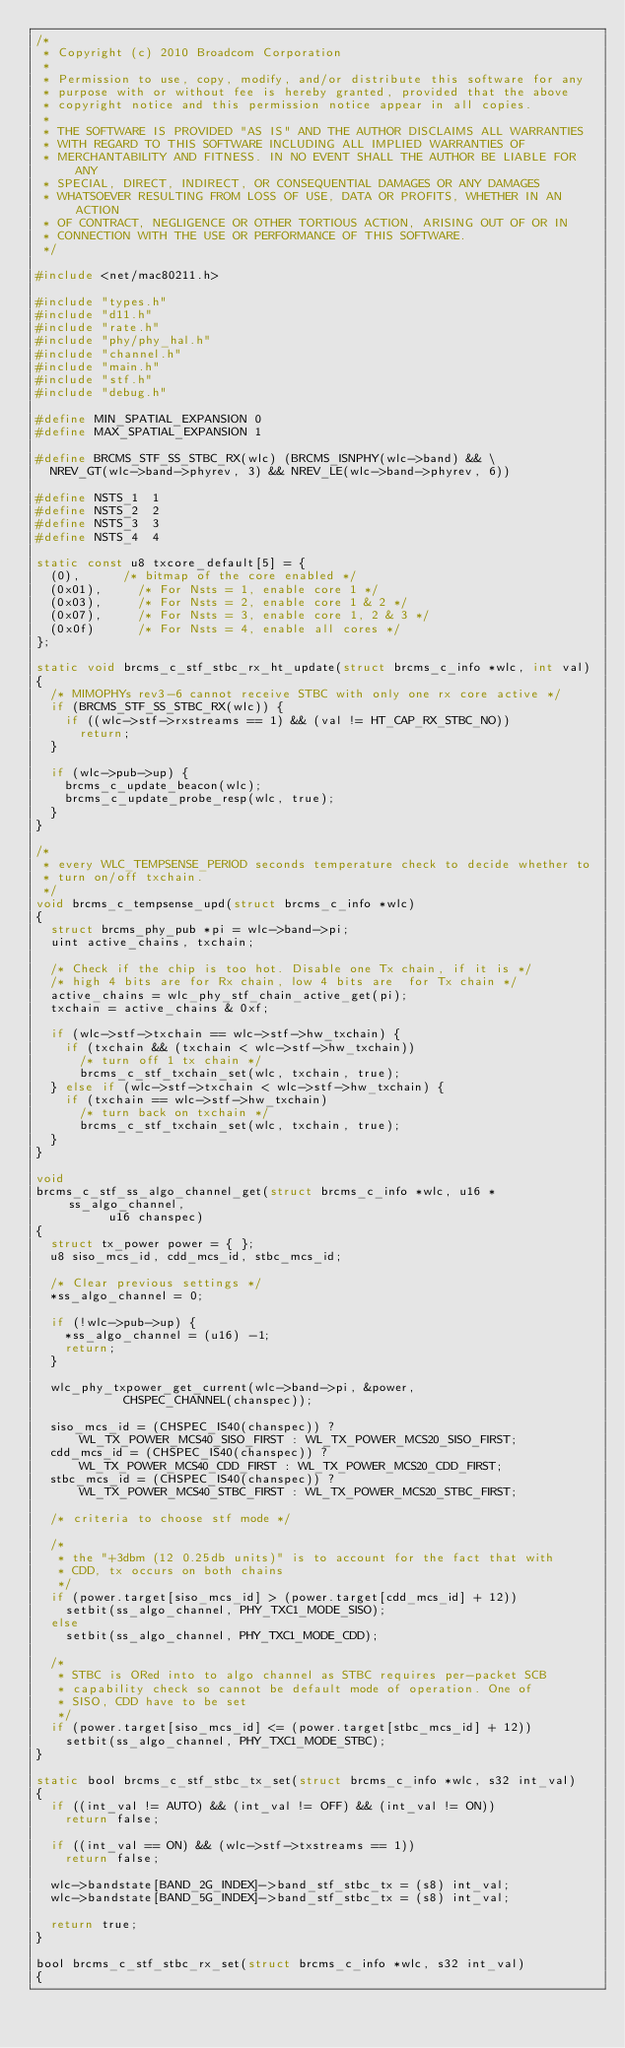Convert code to text. <code><loc_0><loc_0><loc_500><loc_500><_C_>/*
 * Copyright (c) 2010 Broadcom Corporation
 *
 * Permission to use, copy, modify, and/or distribute this software for any
 * purpose with or without fee is hereby granted, provided that the above
 * copyright notice and this permission notice appear in all copies.
 *
 * THE SOFTWARE IS PROVIDED "AS IS" AND THE AUTHOR DISCLAIMS ALL WARRANTIES
 * WITH REGARD TO THIS SOFTWARE INCLUDING ALL IMPLIED WARRANTIES OF
 * MERCHANTABILITY AND FITNESS. IN NO EVENT SHALL THE AUTHOR BE LIABLE FOR ANY
 * SPECIAL, DIRECT, INDIRECT, OR CONSEQUENTIAL DAMAGES OR ANY DAMAGES
 * WHATSOEVER RESULTING FROM LOSS OF USE, DATA OR PROFITS, WHETHER IN AN ACTION
 * OF CONTRACT, NEGLIGENCE OR OTHER TORTIOUS ACTION, ARISING OUT OF OR IN
 * CONNECTION WITH THE USE OR PERFORMANCE OF THIS SOFTWARE.
 */

#include <net/mac80211.h>

#include "types.h"
#include "d11.h"
#include "rate.h"
#include "phy/phy_hal.h"
#include "channel.h"
#include "main.h"
#include "stf.h"
#include "debug.h"

#define MIN_SPATIAL_EXPANSION	0
#define MAX_SPATIAL_EXPANSION	1

#define BRCMS_STF_SS_STBC_RX(wlc) (BRCMS_ISNPHY(wlc->band) && \
	NREV_GT(wlc->band->phyrev, 3) && NREV_LE(wlc->band->phyrev, 6))

#define NSTS_1	1
#define NSTS_2	2
#define NSTS_3	3
#define NSTS_4	4

static const u8 txcore_default[5] = {
	(0),			/* bitmap of the core enabled */
	(0x01),			/* For Nsts = 1, enable core 1 */
	(0x03),			/* For Nsts = 2, enable core 1 & 2 */
	(0x07),			/* For Nsts = 3, enable core 1, 2 & 3 */
	(0x0f)			/* For Nsts = 4, enable all cores */
};

static void brcms_c_stf_stbc_rx_ht_update(struct brcms_c_info *wlc, int val)
{
	/* MIMOPHYs rev3-6 cannot receive STBC with only one rx core active */
	if (BRCMS_STF_SS_STBC_RX(wlc)) {
		if ((wlc->stf->rxstreams == 1) && (val != HT_CAP_RX_STBC_NO))
			return;
	}

	if (wlc->pub->up) {
		brcms_c_update_beacon(wlc);
		brcms_c_update_probe_resp(wlc, true);
	}
}

/*
 * every WLC_TEMPSENSE_PERIOD seconds temperature check to decide whether to
 * turn on/off txchain.
 */
void brcms_c_tempsense_upd(struct brcms_c_info *wlc)
{
	struct brcms_phy_pub *pi = wlc->band->pi;
	uint active_chains, txchain;

	/* Check if the chip is too hot. Disable one Tx chain, if it is */
	/* high 4 bits are for Rx chain, low 4 bits are  for Tx chain */
	active_chains = wlc_phy_stf_chain_active_get(pi);
	txchain = active_chains & 0xf;

	if (wlc->stf->txchain == wlc->stf->hw_txchain) {
		if (txchain && (txchain < wlc->stf->hw_txchain))
			/* turn off 1 tx chain */
			brcms_c_stf_txchain_set(wlc, txchain, true);
	} else if (wlc->stf->txchain < wlc->stf->hw_txchain) {
		if (txchain == wlc->stf->hw_txchain)
			/* turn back on txchain */
			brcms_c_stf_txchain_set(wlc, txchain, true);
	}
}

void
brcms_c_stf_ss_algo_channel_get(struct brcms_c_info *wlc, u16 *ss_algo_channel,
			    u16 chanspec)
{
	struct tx_power power = { };
	u8 siso_mcs_id, cdd_mcs_id, stbc_mcs_id;

	/* Clear previous settings */
	*ss_algo_channel = 0;

	if (!wlc->pub->up) {
		*ss_algo_channel = (u16) -1;
		return;
	}

	wlc_phy_txpower_get_current(wlc->band->pi, &power,
				    CHSPEC_CHANNEL(chanspec));

	siso_mcs_id = (CHSPEC_IS40(chanspec)) ?
	    WL_TX_POWER_MCS40_SISO_FIRST : WL_TX_POWER_MCS20_SISO_FIRST;
	cdd_mcs_id = (CHSPEC_IS40(chanspec)) ?
	    WL_TX_POWER_MCS40_CDD_FIRST : WL_TX_POWER_MCS20_CDD_FIRST;
	stbc_mcs_id = (CHSPEC_IS40(chanspec)) ?
	    WL_TX_POWER_MCS40_STBC_FIRST : WL_TX_POWER_MCS20_STBC_FIRST;

	/* criteria to choose stf mode */

	/*
	 * the "+3dbm (12 0.25db units)" is to account for the fact that with
	 * CDD, tx occurs on both chains
	 */
	if (power.target[siso_mcs_id] > (power.target[cdd_mcs_id] + 12))
		setbit(ss_algo_channel, PHY_TXC1_MODE_SISO);
	else
		setbit(ss_algo_channel, PHY_TXC1_MODE_CDD);

	/*
	 * STBC is ORed into to algo channel as STBC requires per-packet SCB
	 * capability check so cannot be default mode of operation. One of
	 * SISO, CDD have to be set
	 */
	if (power.target[siso_mcs_id] <= (power.target[stbc_mcs_id] + 12))
		setbit(ss_algo_channel, PHY_TXC1_MODE_STBC);
}

static bool brcms_c_stf_stbc_tx_set(struct brcms_c_info *wlc, s32 int_val)
{
	if ((int_val != AUTO) && (int_val != OFF) && (int_val != ON))
		return false;

	if ((int_val == ON) && (wlc->stf->txstreams == 1))
		return false;

	wlc->bandstate[BAND_2G_INDEX]->band_stf_stbc_tx = (s8) int_val;
	wlc->bandstate[BAND_5G_INDEX]->band_stf_stbc_tx = (s8) int_val;

	return true;
}

bool brcms_c_stf_stbc_rx_set(struct brcms_c_info *wlc, s32 int_val)
{</code> 